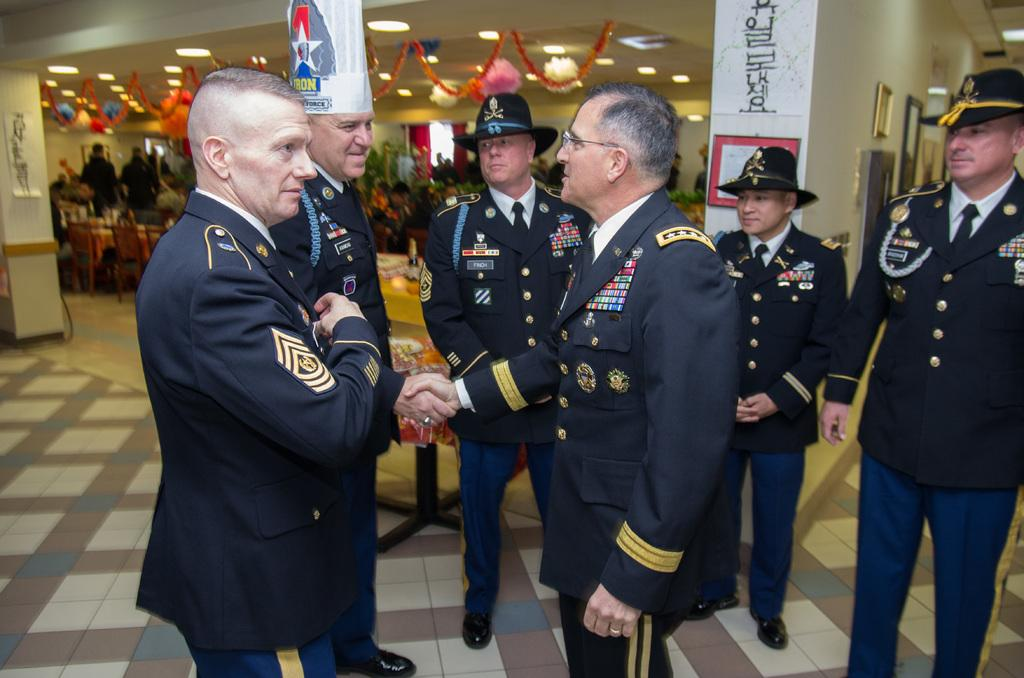How many people are in the image? There are people in the image, but the exact number is not specified. What are the people wearing in the image? The people are wearing the same costume in the image. What objects can be seen in the image that are related to photography? Photo frames are visible in the image. What type of lighting is present in the image? There are lights in the image. What additional decorative elements can be seen in the image? There are decorative objects in the image. What type of whip is being used to prepare dinner in the image? There is no whip or dinner preparation visible in the image. 